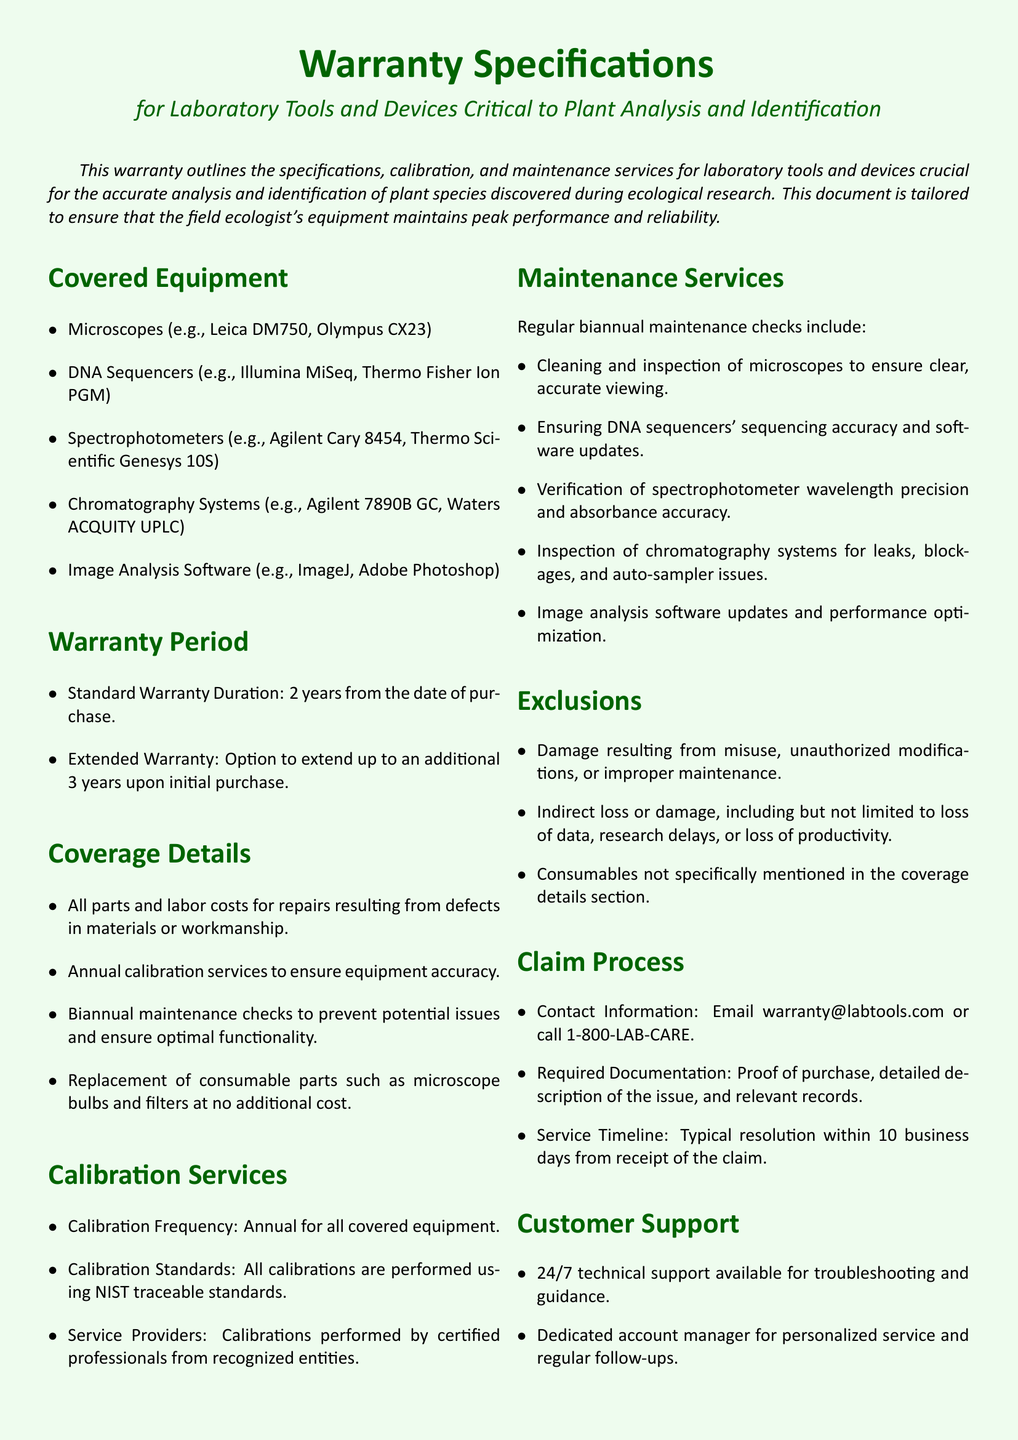What is the standard warranty duration? The standard warranty duration stated in the document is 2 years from the date of purchase.
Answer: 2 years Which microscopes are covered under the warranty? The document lists specific microscopes covered under the warranty including Leica DM750 and Olympus CX23.
Answer: Leica DM750, Olympus CX23 How often are calibration services provided? Calibration services are mentioned to be performed annually for all covered equipment in the document.
Answer: Annual What types of devices are included in the maintenance checks? The document provides details on the types of devices included in the biannual maintenance checks, specifically microscopes, DNA sequencers, spectrophotometers, and chromatography systems.
Answer: Microscopes, DNA sequencers, spectrophotometers, chromatography systems What is excluded from the warranty coverage? The document outlines exclusions from the warranty, including damage from misuse and indirect loss or damage, among others.
Answer: Damage from misuse, indirect loss or damage What is the typical resolution timeline for a claim? The document states that the typical resolution timeline for a claim is within 10 business days from receipt of the claim.
Answer: 10 business days What is the contact email for warranty claims? The document provides a specific email address for warranty claims, which is warranty@labtools.com.
Answer: warranty@labtools.com How many maintenance checks are conducted per year? The document specifies that regular maintenance checks are conducted biannually, which means twice a year.
Answer: Biannually 